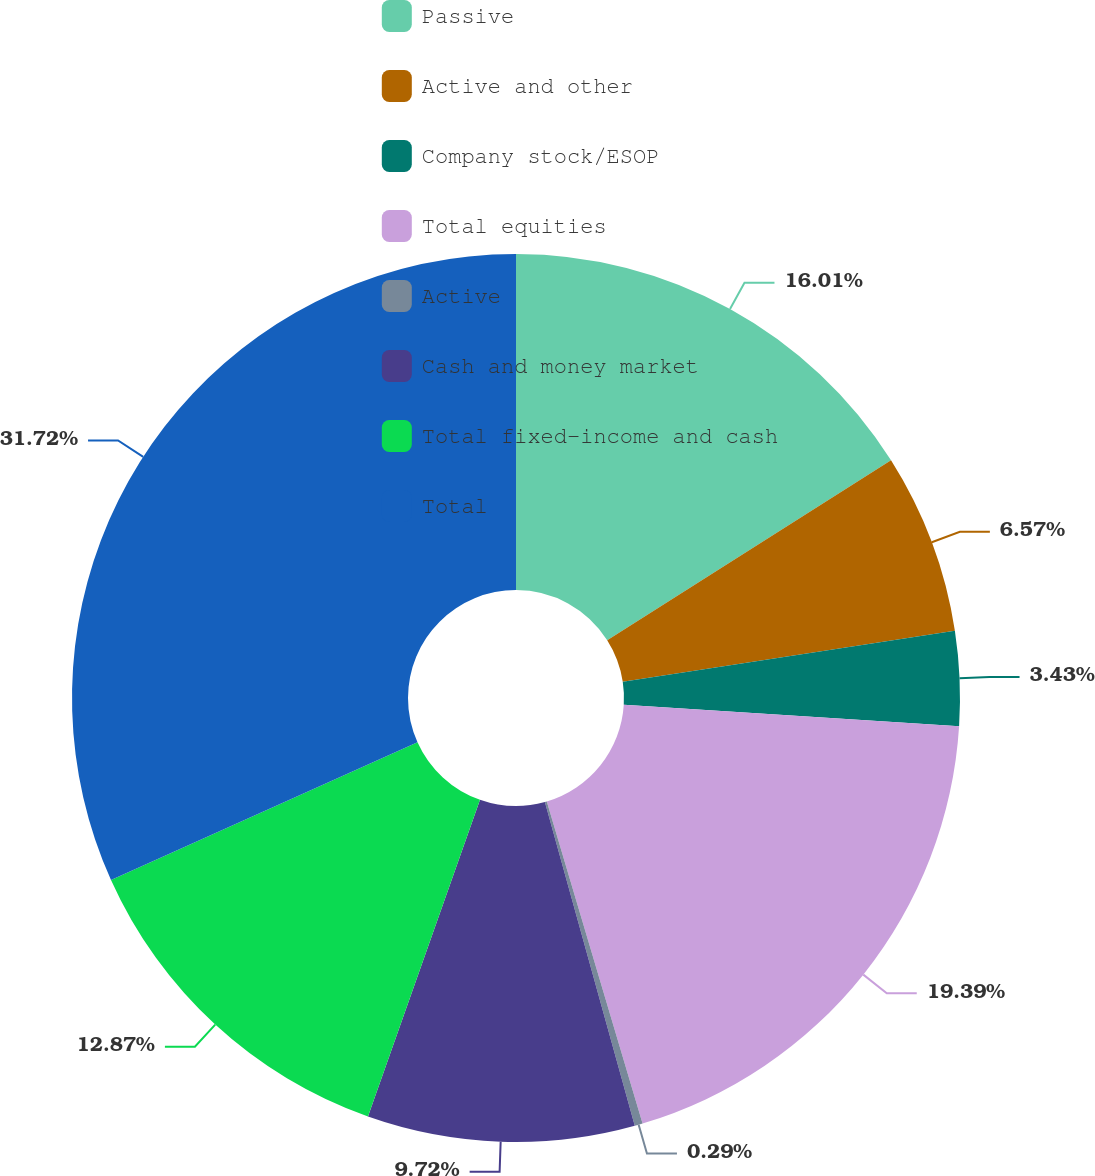<chart> <loc_0><loc_0><loc_500><loc_500><pie_chart><fcel>Passive<fcel>Active and other<fcel>Company stock/ESOP<fcel>Total equities<fcel>Active<fcel>Cash and money market<fcel>Total fixed-income and cash<fcel>Total<nl><fcel>16.01%<fcel>6.57%<fcel>3.43%<fcel>19.39%<fcel>0.29%<fcel>9.72%<fcel>12.87%<fcel>31.72%<nl></chart> 